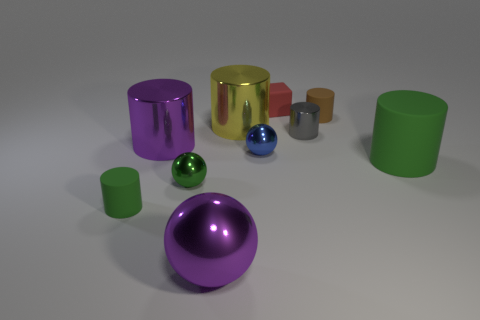Do the small gray metal thing that is right of the tiny blue sphere and the small red object have the same shape?
Give a very brief answer. No. How many things are either big rubber things or large purple metal objects in front of the blue metal ball?
Offer a terse response. 2. Are there fewer tiny cyan objects than metallic objects?
Your response must be concise. Yes. Are there more tiny red blocks than metallic cylinders?
Your response must be concise. No. What number of other things are the same material as the blue thing?
Your answer should be compact. 5. How many red objects are behind the metallic sphere that is behind the large cylinder that is on the right side of the gray thing?
Ensure brevity in your answer.  1. How many rubber things are either big purple cylinders or tiny blue spheres?
Your response must be concise. 0. There is a yellow shiny object that is left of the ball behind the green shiny object; what is its size?
Offer a terse response. Large. Is the color of the tiny cylinder that is behind the gray cylinder the same as the tiny rubber cylinder in front of the tiny gray thing?
Provide a succinct answer. No. What is the color of the big object that is in front of the gray metal cylinder and right of the large purple shiny ball?
Give a very brief answer. Green. 